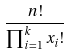Convert formula to latex. <formula><loc_0><loc_0><loc_500><loc_500>\frac { n ! } { \prod _ { i = 1 } ^ { k } x _ { i } ! }</formula> 